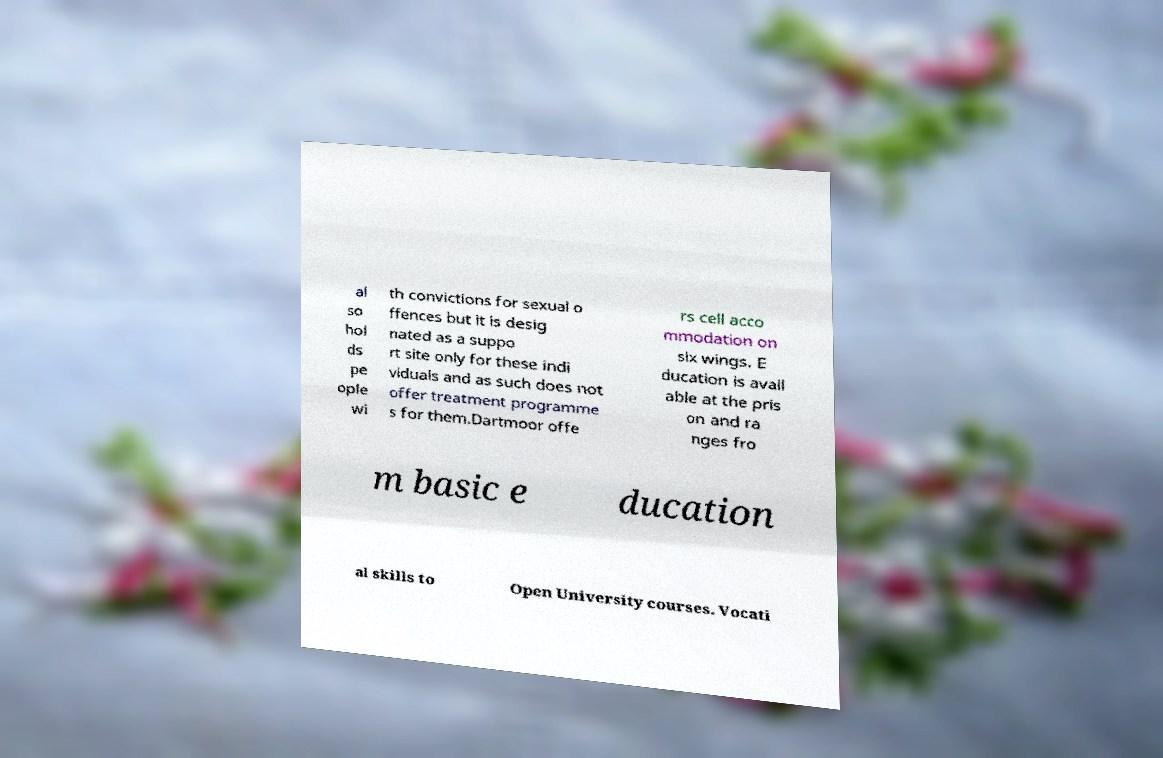Can you read and provide the text displayed in the image?This photo seems to have some interesting text. Can you extract and type it out for me? al so hol ds pe ople wi th convictions for sexual o ffences but it is desig nated as a suppo rt site only for these indi viduals and as such does not offer treatment programme s for them.Dartmoor offe rs cell acco mmodation on six wings. E ducation is avail able at the pris on and ra nges fro m basic e ducation al skills to Open University courses. Vocati 